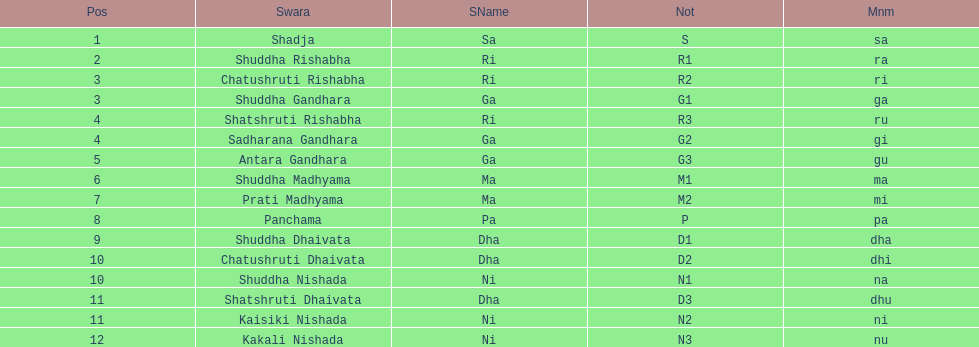Which swara follows immediately after antara gandhara? Shuddha Madhyama. 